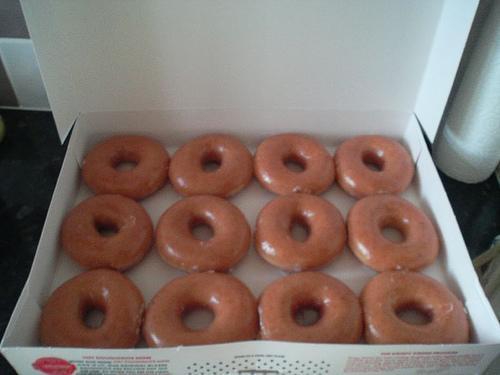How many chocolate doughnuts are there?
Give a very brief answer. 0. How many donuts can be seen?
Give a very brief answer. 12. How many red umbrellas are there?
Give a very brief answer. 0. 